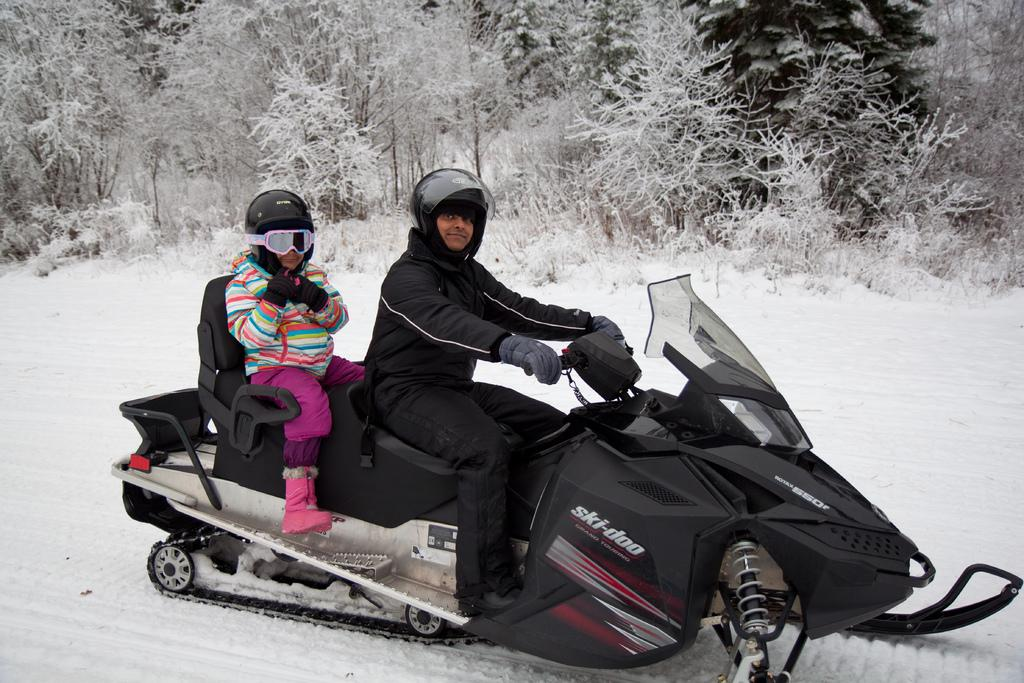How many people are in the image? There are two people in the image. What are the people wearing on their heads? The people are wearing helmets. What are the people sitting on in the image? The people are sitting on a vehicle. What type of weather is depicted in the image? There is snow visible in the image. What type of vegetation can be seen in the image? There are plants and trees in the image. What type of oven can be seen in the image? There is no oven present in the image. What type of carriage are the people riding in the image? The people are sitting on a vehicle, but it is not a carriage. 